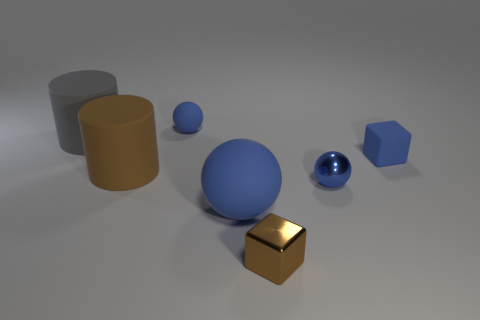Add 1 big purple things. How many objects exist? 8 Subtract all blocks. How many objects are left? 5 Add 5 blue things. How many blue things are left? 9 Add 3 cylinders. How many cylinders exist? 5 Subtract 0 gray balls. How many objects are left? 7 Subtract all small yellow rubber cylinders. Subtract all blue metal balls. How many objects are left? 6 